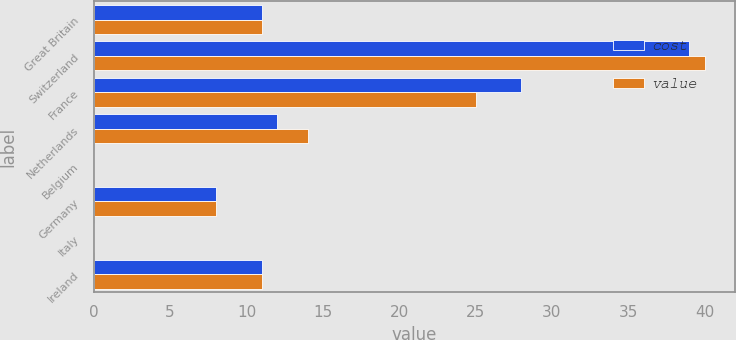<chart> <loc_0><loc_0><loc_500><loc_500><stacked_bar_chart><ecel><fcel>Great Britain<fcel>Switzerland<fcel>France<fcel>Netherlands<fcel>Belgium<fcel>Germany<fcel>Italy<fcel>Ireland<nl><fcel>cost<fcel>11<fcel>39<fcel>28<fcel>12<fcel>0<fcel>8<fcel>0<fcel>11<nl><fcel>value<fcel>11<fcel>40<fcel>25<fcel>14<fcel>0<fcel>8<fcel>0<fcel>11<nl></chart> 